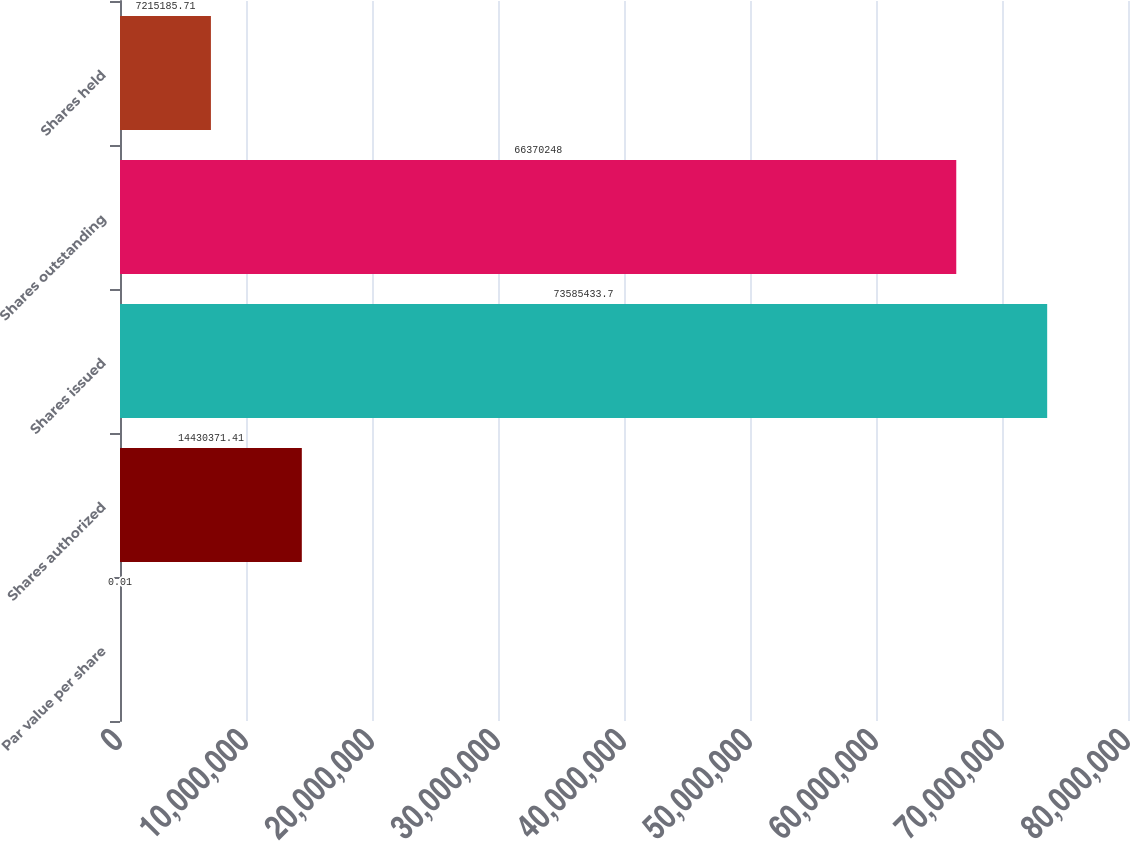<chart> <loc_0><loc_0><loc_500><loc_500><bar_chart><fcel>Par value per share<fcel>Shares authorized<fcel>Shares issued<fcel>Shares outstanding<fcel>Shares held<nl><fcel>0.01<fcel>1.44304e+07<fcel>7.35854e+07<fcel>6.63702e+07<fcel>7.21519e+06<nl></chart> 